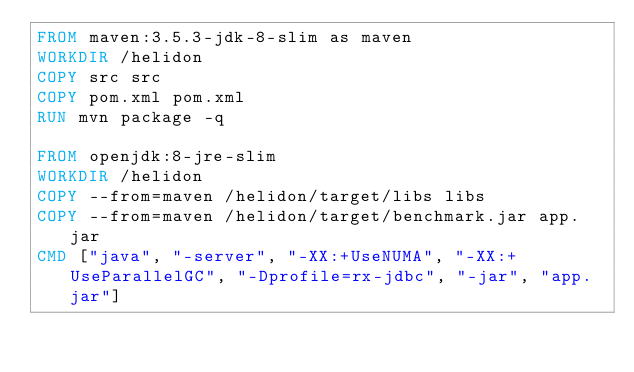Convert code to text. <code><loc_0><loc_0><loc_500><loc_500><_Dockerfile_>FROM maven:3.5.3-jdk-8-slim as maven
WORKDIR /helidon
COPY src src
COPY pom.xml pom.xml
RUN mvn package -q

FROM openjdk:8-jre-slim
WORKDIR /helidon
COPY --from=maven /helidon/target/libs libs
COPY --from=maven /helidon/target/benchmark.jar app.jar
CMD ["java", "-server", "-XX:+UseNUMA", "-XX:+UseParallelGC", "-Dprofile=rx-jdbc", "-jar", "app.jar"]
</code> 